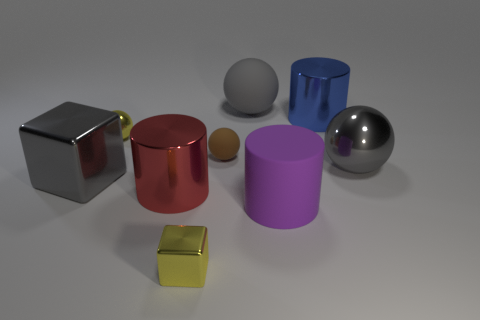What is the shape of the small rubber thing? The small rubber object appears to be a gray sphere, which is a perfectly round geometrical object in three-dimensional space, similar to a round ball. 